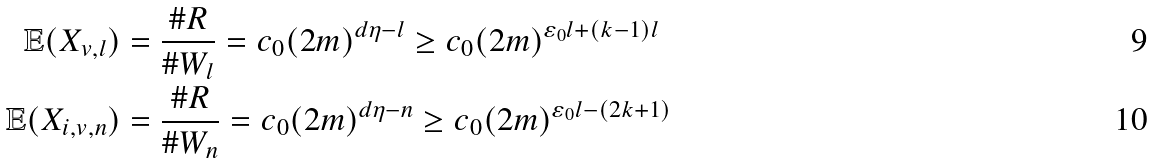<formula> <loc_0><loc_0><loc_500><loc_500>\mathbb { E } ( X _ { v , l } ) & = \frac { \# R } { \# W _ { l } } = c _ { 0 } ( 2 m ) ^ { d \eta - l } \geq c _ { 0 } ( 2 m ) ^ { \varepsilon _ { 0 } l + ( k - 1 ) l } \\ \mathbb { E } ( X _ { i , v , n } ) & = \frac { \# R } { \# W _ { n } } = c _ { 0 } ( 2 m ) ^ { d \eta - n } \geq c _ { 0 } ( 2 m ) ^ { \varepsilon _ { 0 } l - ( 2 k + 1 ) }</formula> 